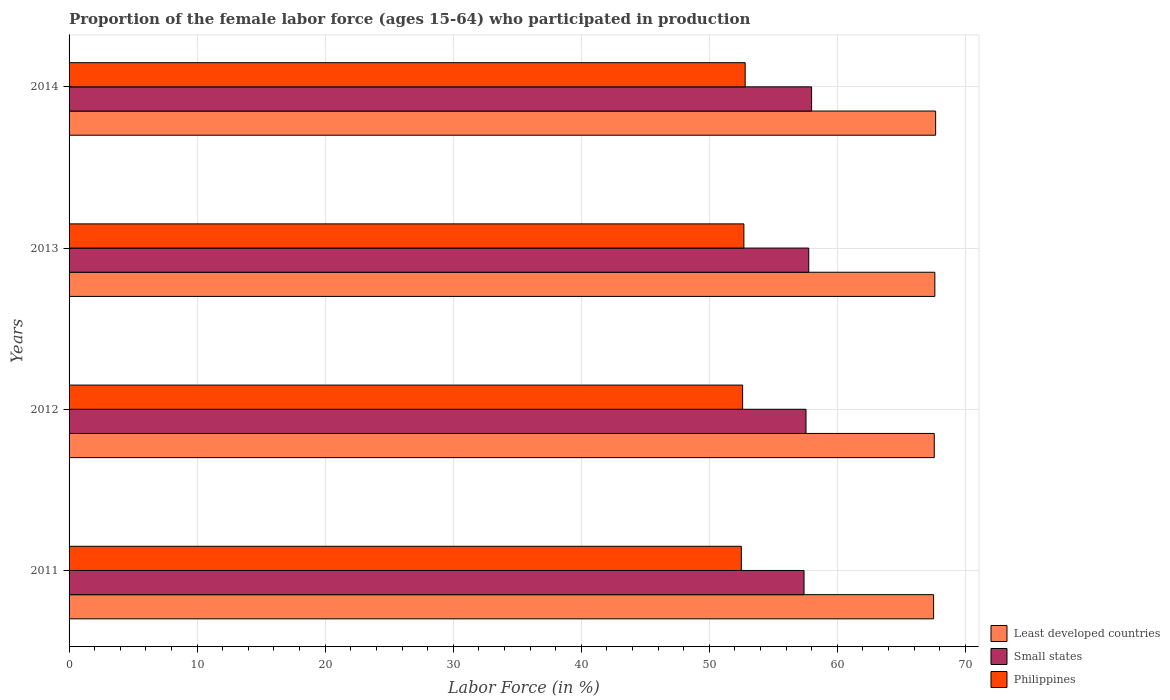How many different coloured bars are there?
Your answer should be compact. 3. How many groups of bars are there?
Make the answer very short. 4. Are the number of bars per tick equal to the number of legend labels?
Provide a short and direct response. Yes. Are the number of bars on each tick of the Y-axis equal?
Give a very brief answer. Yes. How many bars are there on the 3rd tick from the top?
Your answer should be compact. 3. What is the label of the 4th group of bars from the top?
Offer a very short reply. 2011. What is the proportion of the female labor force who participated in production in Least developed countries in 2014?
Provide a succinct answer. 67.67. Across all years, what is the maximum proportion of the female labor force who participated in production in Least developed countries?
Your answer should be compact. 67.67. Across all years, what is the minimum proportion of the female labor force who participated in production in Least developed countries?
Your answer should be very brief. 67.51. What is the total proportion of the female labor force who participated in production in Small states in the graph?
Your response must be concise. 230.7. What is the difference between the proportion of the female labor force who participated in production in Small states in 2011 and that in 2014?
Make the answer very short. -0.59. What is the difference between the proportion of the female labor force who participated in production in Philippines in 2011 and the proportion of the female labor force who participated in production in Small states in 2013?
Ensure brevity in your answer.  -5.26. What is the average proportion of the female labor force who participated in production in Small states per year?
Keep it short and to the point. 57.67. In the year 2014, what is the difference between the proportion of the female labor force who participated in production in Small states and proportion of the female labor force who participated in production in Least developed countries?
Offer a terse response. -9.69. What is the ratio of the proportion of the female labor force who participated in production in Philippines in 2011 to that in 2012?
Your response must be concise. 1. Is the difference between the proportion of the female labor force who participated in production in Small states in 2011 and 2013 greater than the difference between the proportion of the female labor force who participated in production in Least developed countries in 2011 and 2013?
Offer a terse response. No. What is the difference between the highest and the second highest proportion of the female labor force who participated in production in Small states?
Provide a short and direct response. 0.22. What is the difference between the highest and the lowest proportion of the female labor force who participated in production in Small states?
Your response must be concise. 0.59. What does the 1st bar from the top in 2011 represents?
Provide a short and direct response. Philippines. What does the 3rd bar from the bottom in 2011 represents?
Offer a very short reply. Philippines. Is it the case that in every year, the sum of the proportion of the female labor force who participated in production in Philippines and proportion of the female labor force who participated in production in Least developed countries is greater than the proportion of the female labor force who participated in production in Small states?
Offer a terse response. Yes. How many bars are there?
Provide a succinct answer. 12. How many years are there in the graph?
Give a very brief answer. 4. What is the difference between two consecutive major ticks on the X-axis?
Keep it short and to the point. 10. Are the values on the major ticks of X-axis written in scientific E-notation?
Give a very brief answer. No. How many legend labels are there?
Offer a terse response. 3. How are the legend labels stacked?
Make the answer very short. Vertical. What is the title of the graph?
Offer a terse response. Proportion of the female labor force (ages 15-64) who participated in production. Does "Romania" appear as one of the legend labels in the graph?
Keep it short and to the point. No. What is the label or title of the X-axis?
Give a very brief answer. Labor Force (in %). What is the label or title of the Y-axis?
Provide a succinct answer. Years. What is the Labor Force (in %) of Least developed countries in 2011?
Keep it short and to the point. 67.51. What is the Labor Force (in %) of Small states in 2011?
Offer a very short reply. 57.4. What is the Labor Force (in %) in Philippines in 2011?
Your answer should be very brief. 52.5. What is the Labor Force (in %) of Least developed countries in 2012?
Your answer should be very brief. 67.57. What is the Labor Force (in %) of Small states in 2012?
Ensure brevity in your answer.  57.55. What is the Labor Force (in %) in Philippines in 2012?
Give a very brief answer. 52.6. What is the Labor Force (in %) of Least developed countries in 2013?
Offer a terse response. 67.61. What is the Labor Force (in %) of Small states in 2013?
Your answer should be very brief. 57.76. What is the Labor Force (in %) in Philippines in 2013?
Your response must be concise. 52.7. What is the Labor Force (in %) in Least developed countries in 2014?
Give a very brief answer. 67.67. What is the Labor Force (in %) in Small states in 2014?
Give a very brief answer. 57.99. What is the Labor Force (in %) in Philippines in 2014?
Provide a succinct answer. 52.8. Across all years, what is the maximum Labor Force (in %) of Least developed countries?
Offer a terse response. 67.67. Across all years, what is the maximum Labor Force (in %) in Small states?
Give a very brief answer. 57.99. Across all years, what is the maximum Labor Force (in %) in Philippines?
Make the answer very short. 52.8. Across all years, what is the minimum Labor Force (in %) in Least developed countries?
Keep it short and to the point. 67.51. Across all years, what is the minimum Labor Force (in %) in Small states?
Keep it short and to the point. 57.4. Across all years, what is the minimum Labor Force (in %) of Philippines?
Your response must be concise. 52.5. What is the total Labor Force (in %) of Least developed countries in the graph?
Your response must be concise. 270.37. What is the total Labor Force (in %) in Small states in the graph?
Your response must be concise. 230.7. What is the total Labor Force (in %) of Philippines in the graph?
Make the answer very short. 210.6. What is the difference between the Labor Force (in %) in Least developed countries in 2011 and that in 2012?
Ensure brevity in your answer.  -0.05. What is the difference between the Labor Force (in %) of Small states in 2011 and that in 2012?
Ensure brevity in your answer.  -0.15. What is the difference between the Labor Force (in %) in Least developed countries in 2011 and that in 2013?
Your answer should be very brief. -0.1. What is the difference between the Labor Force (in %) of Small states in 2011 and that in 2013?
Your response must be concise. -0.37. What is the difference between the Labor Force (in %) in Philippines in 2011 and that in 2013?
Your answer should be very brief. -0.2. What is the difference between the Labor Force (in %) of Least developed countries in 2011 and that in 2014?
Your answer should be compact. -0.16. What is the difference between the Labor Force (in %) of Small states in 2011 and that in 2014?
Your answer should be compact. -0.59. What is the difference between the Labor Force (in %) in Least developed countries in 2012 and that in 2013?
Provide a succinct answer. -0.05. What is the difference between the Labor Force (in %) in Small states in 2012 and that in 2013?
Your response must be concise. -0.21. What is the difference between the Labor Force (in %) of Least developed countries in 2012 and that in 2014?
Your response must be concise. -0.11. What is the difference between the Labor Force (in %) in Small states in 2012 and that in 2014?
Offer a very short reply. -0.44. What is the difference between the Labor Force (in %) in Least developed countries in 2013 and that in 2014?
Provide a succinct answer. -0.06. What is the difference between the Labor Force (in %) in Small states in 2013 and that in 2014?
Make the answer very short. -0.22. What is the difference between the Labor Force (in %) of Least developed countries in 2011 and the Labor Force (in %) of Small states in 2012?
Offer a terse response. 9.96. What is the difference between the Labor Force (in %) of Least developed countries in 2011 and the Labor Force (in %) of Philippines in 2012?
Give a very brief answer. 14.91. What is the difference between the Labor Force (in %) of Small states in 2011 and the Labor Force (in %) of Philippines in 2012?
Keep it short and to the point. 4.8. What is the difference between the Labor Force (in %) in Least developed countries in 2011 and the Labor Force (in %) in Small states in 2013?
Provide a short and direct response. 9.75. What is the difference between the Labor Force (in %) in Least developed countries in 2011 and the Labor Force (in %) in Philippines in 2013?
Provide a succinct answer. 14.81. What is the difference between the Labor Force (in %) of Small states in 2011 and the Labor Force (in %) of Philippines in 2013?
Offer a very short reply. 4.7. What is the difference between the Labor Force (in %) of Least developed countries in 2011 and the Labor Force (in %) of Small states in 2014?
Provide a succinct answer. 9.53. What is the difference between the Labor Force (in %) of Least developed countries in 2011 and the Labor Force (in %) of Philippines in 2014?
Ensure brevity in your answer.  14.71. What is the difference between the Labor Force (in %) of Small states in 2011 and the Labor Force (in %) of Philippines in 2014?
Your answer should be compact. 4.6. What is the difference between the Labor Force (in %) of Least developed countries in 2012 and the Labor Force (in %) of Small states in 2013?
Offer a terse response. 9.8. What is the difference between the Labor Force (in %) in Least developed countries in 2012 and the Labor Force (in %) in Philippines in 2013?
Your response must be concise. 14.87. What is the difference between the Labor Force (in %) in Small states in 2012 and the Labor Force (in %) in Philippines in 2013?
Give a very brief answer. 4.85. What is the difference between the Labor Force (in %) in Least developed countries in 2012 and the Labor Force (in %) in Small states in 2014?
Your answer should be compact. 9.58. What is the difference between the Labor Force (in %) in Least developed countries in 2012 and the Labor Force (in %) in Philippines in 2014?
Offer a very short reply. 14.77. What is the difference between the Labor Force (in %) in Small states in 2012 and the Labor Force (in %) in Philippines in 2014?
Your answer should be compact. 4.75. What is the difference between the Labor Force (in %) of Least developed countries in 2013 and the Labor Force (in %) of Small states in 2014?
Provide a succinct answer. 9.62. What is the difference between the Labor Force (in %) of Least developed countries in 2013 and the Labor Force (in %) of Philippines in 2014?
Offer a terse response. 14.81. What is the difference between the Labor Force (in %) of Small states in 2013 and the Labor Force (in %) of Philippines in 2014?
Your answer should be very brief. 4.96. What is the average Labor Force (in %) of Least developed countries per year?
Provide a succinct answer. 67.59. What is the average Labor Force (in %) in Small states per year?
Offer a terse response. 57.67. What is the average Labor Force (in %) in Philippines per year?
Your response must be concise. 52.65. In the year 2011, what is the difference between the Labor Force (in %) of Least developed countries and Labor Force (in %) of Small states?
Provide a short and direct response. 10.12. In the year 2011, what is the difference between the Labor Force (in %) of Least developed countries and Labor Force (in %) of Philippines?
Your answer should be very brief. 15.01. In the year 2011, what is the difference between the Labor Force (in %) in Small states and Labor Force (in %) in Philippines?
Your answer should be compact. 4.9. In the year 2012, what is the difference between the Labor Force (in %) in Least developed countries and Labor Force (in %) in Small states?
Give a very brief answer. 10.02. In the year 2012, what is the difference between the Labor Force (in %) in Least developed countries and Labor Force (in %) in Philippines?
Offer a very short reply. 14.97. In the year 2012, what is the difference between the Labor Force (in %) of Small states and Labor Force (in %) of Philippines?
Offer a terse response. 4.95. In the year 2013, what is the difference between the Labor Force (in %) in Least developed countries and Labor Force (in %) in Small states?
Ensure brevity in your answer.  9.85. In the year 2013, what is the difference between the Labor Force (in %) in Least developed countries and Labor Force (in %) in Philippines?
Your answer should be very brief. 14.91. In the year 2013, what is the difference between the Labor Force (in %) in Small states and Labor Force (in %) in Philippines?
Offer a very short reply. 5.06. In the year 2014, what is the difference between the Labor Force (in %) of Least developed countries and Labor Force (in %) of Small states?
Your answer should be very brief. 9.69. In the year 2014, what is the difference between the Labor Force (in %) in Least developed countries and Labor Force (in %) in Philippines?
Provide a succinct answer. 14.87. In the year 2014, what is the difference between the Labor Force (in %) in Small states and Labor Force (in %) in Philippines?
Your answer should be compact. 5.19. What is the ratio of the Labor Force (in %) of Least developed countries in 2011 to that in 2012?
Make the answer very short. 1. What is the ratio of the Labor Force (in %) in Small states in 2011 to that in 2013?
Provide a short and direct response. 0.99. What is the ratio of the Labor Force (in %) in Philippines in 2011 to that in 2013?
Make the answer very short. 1. What is the ratio of the Labor Force (in %) in Small states in 2011 to that in 2014?
Your answer should be very brief. 0.99. What is the ratio of the Labor Force (in %) in Philippines in 2012 to that in 2013?
Provide a succinct answer. 1. What is the ratio of the Labor Force (in %) of Least developed countries in 2012 to that in 2014?
Provide a short and direct response. 1. What is the ratio of the Labor Force (in %) in Small states in 2013 to that in 2014?
Offer a very short reply. 1. What is the difference between the highest and the second highest Labor Force (in %) of Least developed countries?
Provide a succinct answer. 0.06. What is the difference between the highest and the second highest Labor Force (in %) in Small states?
Your answer should be compact. 0.22. What is the difference between the highest and the lowest Labor Force (in %) of Least developed countries?
Keep it short and to the point. 0.16. What is the difference between the highest and the lowest Labor Force (in %) of Small states?
Your response must be concise. 0.59. What is the difference between the highest and the lowest Labor Force (in %) in Philippines?
Ensure brevity in your answer.  0.3. 